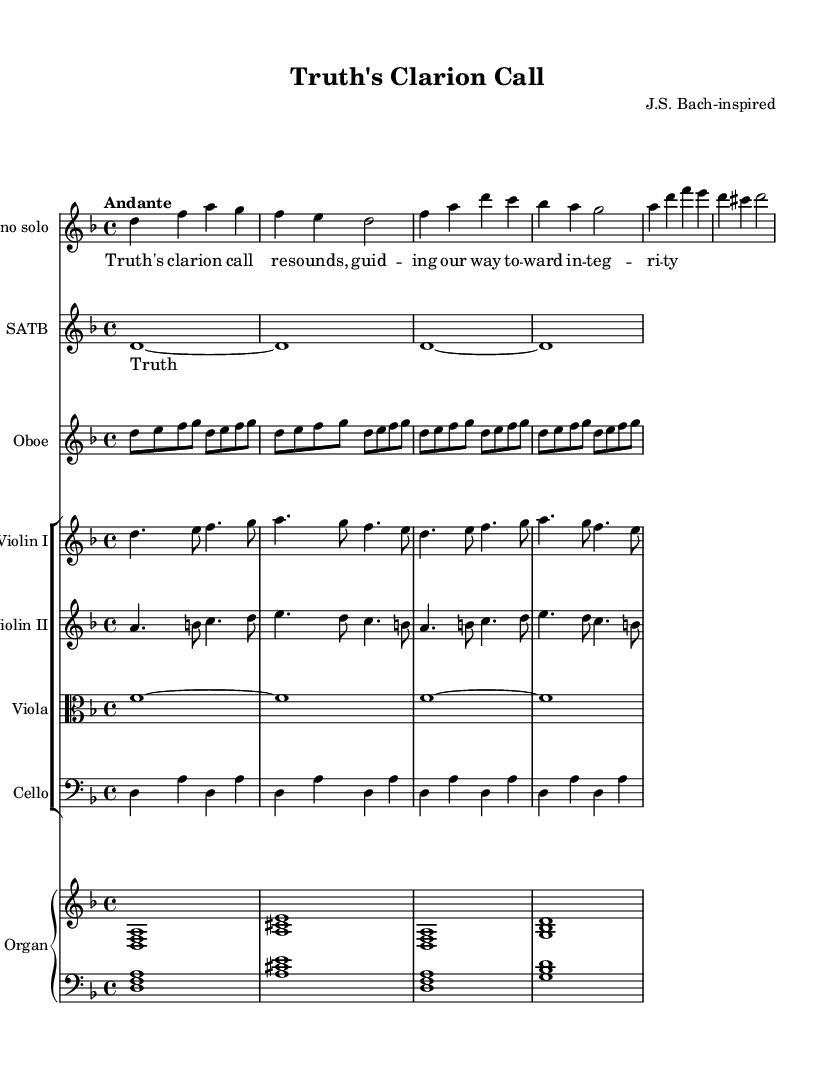What is the key signature of this music? The key signature indicates one flat, referred to as B flat, which defines the music as being in D minor.
Answer: D minor What is the time signature of this piece? The time signature is indicated at the beginning and shows four beats per measure, which is typical for Baroque music, indicating a 4/4 or common time.
Answer: 4/4 What is the tempo marking for this work? The tempo is marked "Andante," suggesting a moderate pace suitable for the reflective nature of a cantata.
Answer: Andante How many voices are present in the vocal parts? There is a soprano solo and a choir part, making a total of two distinct vocal parts.
Answer: Two What instrumental accompaniment does the soprano have? The soprano has the accompaniment of an oboe, violins, viola, cello, and organ, which are typical of Baroque sacred cantatas.
Answer: Oboe, violins, viola, cello, organ What type of form might this piece reflect based on the style? The structure likely reflects the da capo aria form commonly found in Baroque music, characterized by an A-B-A format.
Answer: Da capo aria Which sacred theme is reflected in the text of the piece? The lyrics focus on integrity and moral guidance, aligning with the ethical themes often present in sacred cantatas.
Answer: Integrity 